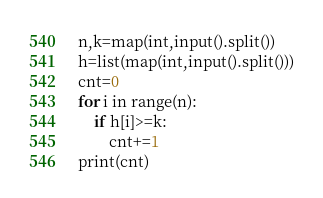<code> <loc_0><loc_0><loc_500><loc_500><_Python_>n,k=map(int,input().split())
h=list(map(int,input().split()))
cnt=0
for i in range(n):
    if h[i]>=k:
        cnt+=1
print(cnt)</code> 